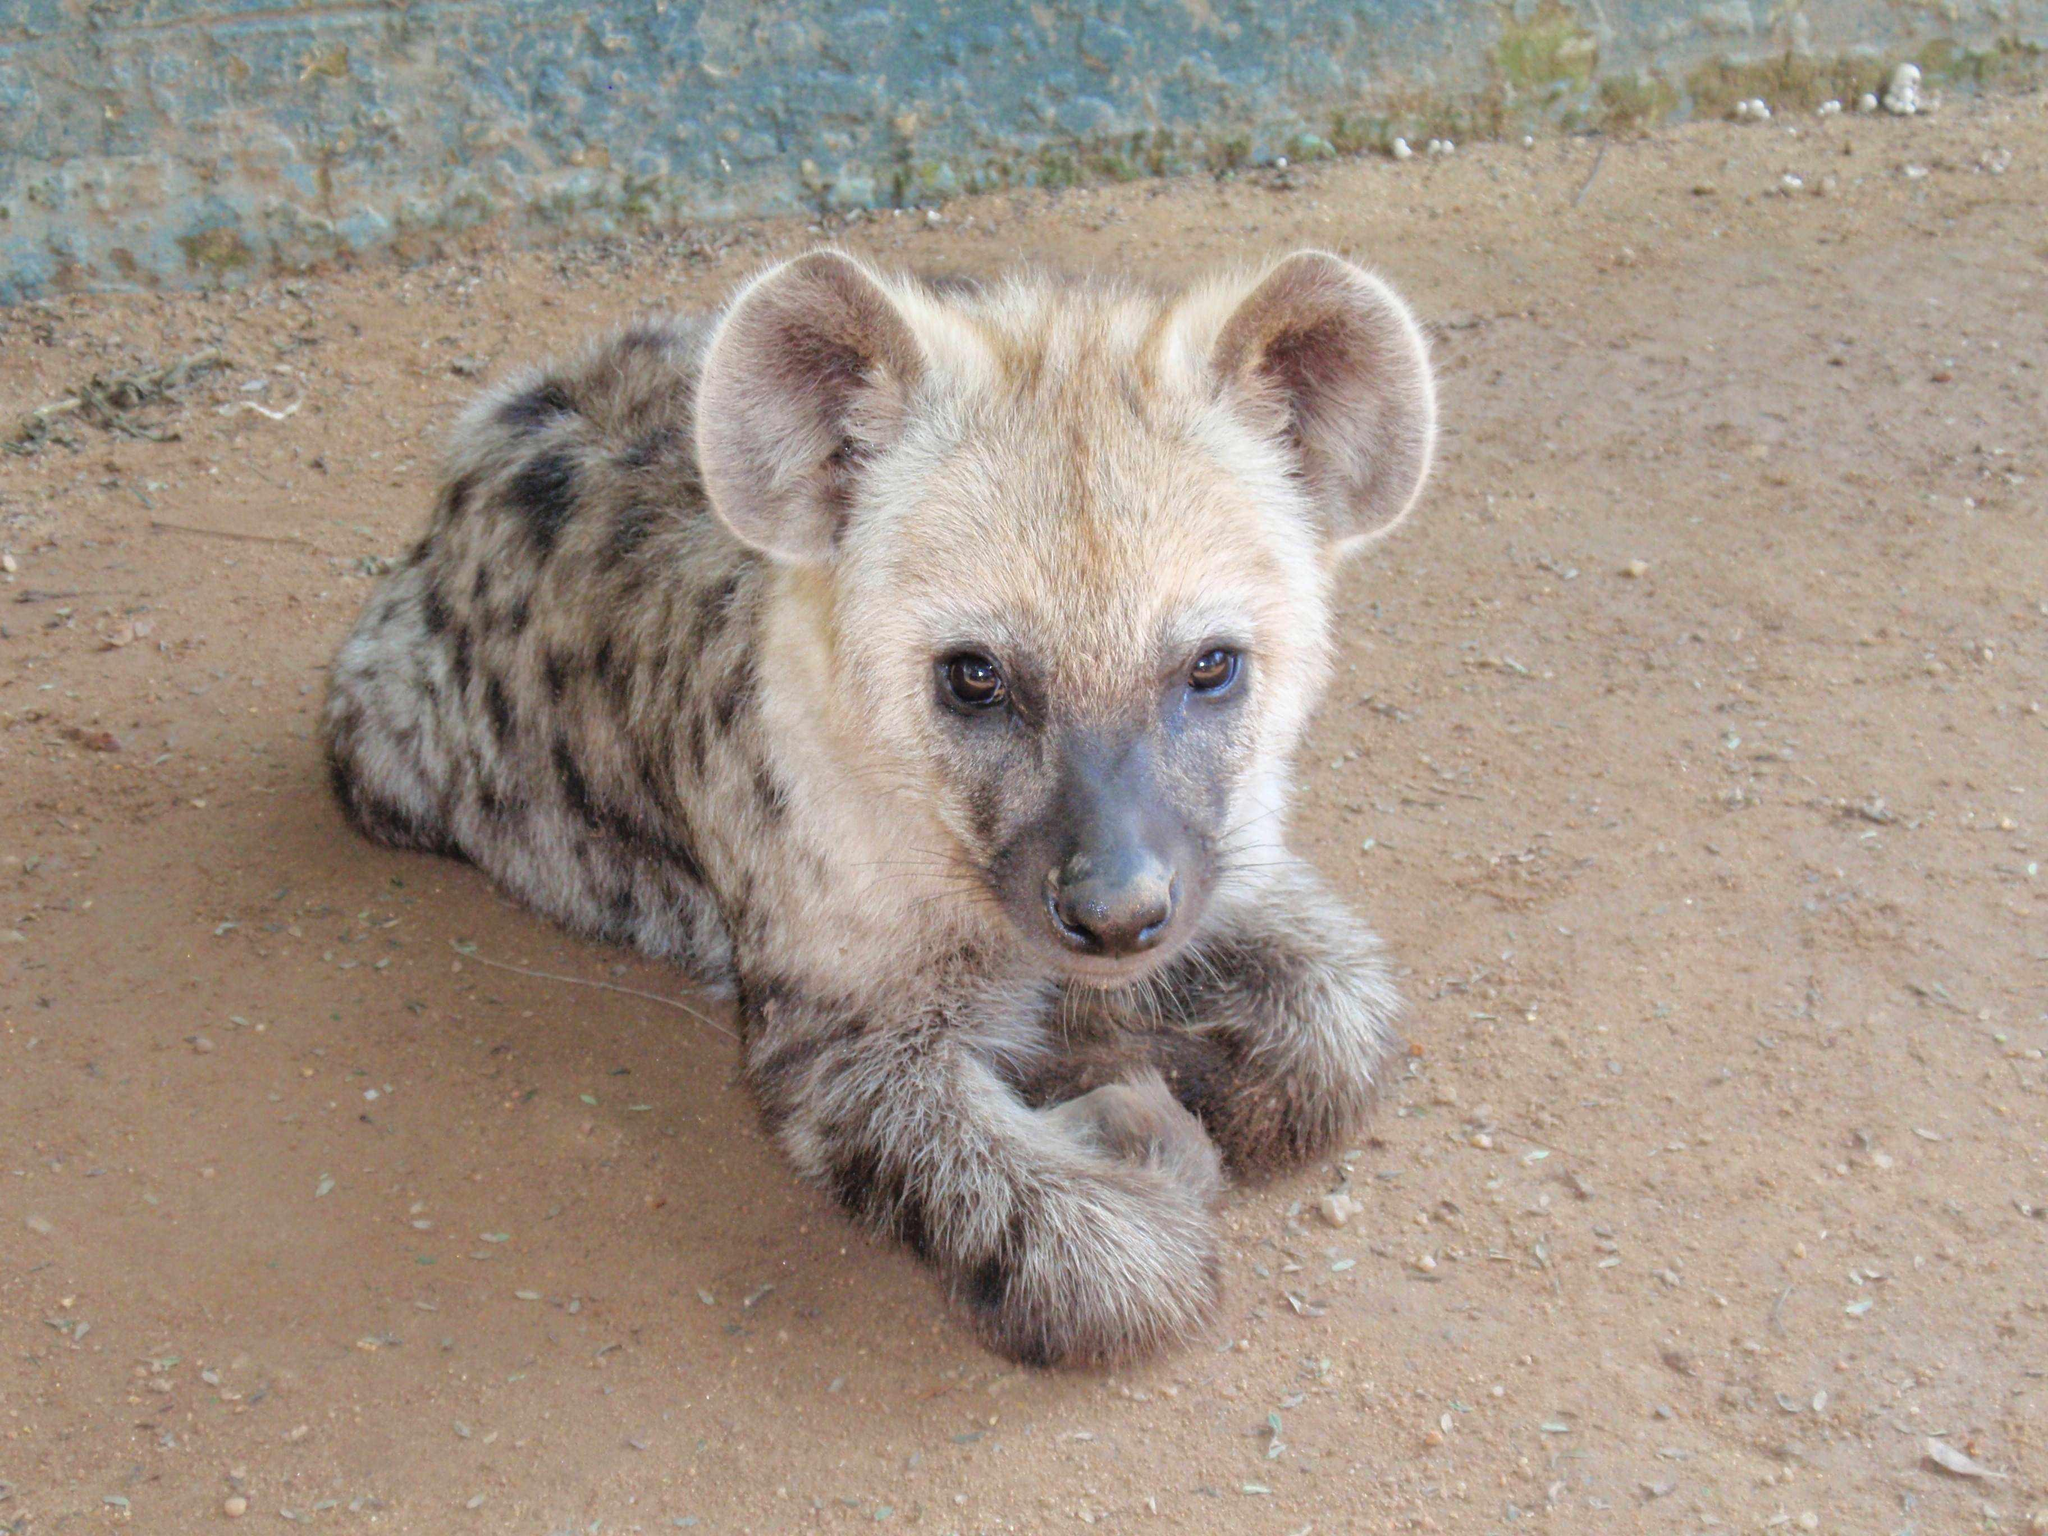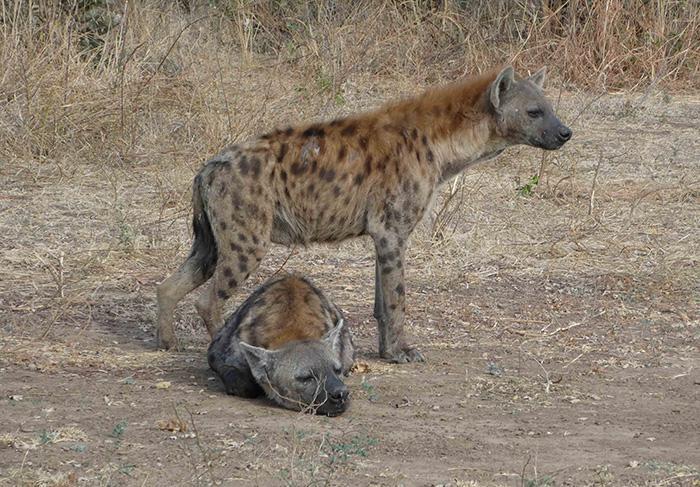The first image is the image on the left, the second image is the image on the right. Analyze the images presented: Is the assertion "Two hyenas are visible." valid? Answer yes or no. No. The first image is the image on the left, the second image is the image on the right. Examine the images to the left and right. Is the description "There is at least one hyena laying on the ground." accurate? Answer yes or no. Yes. 